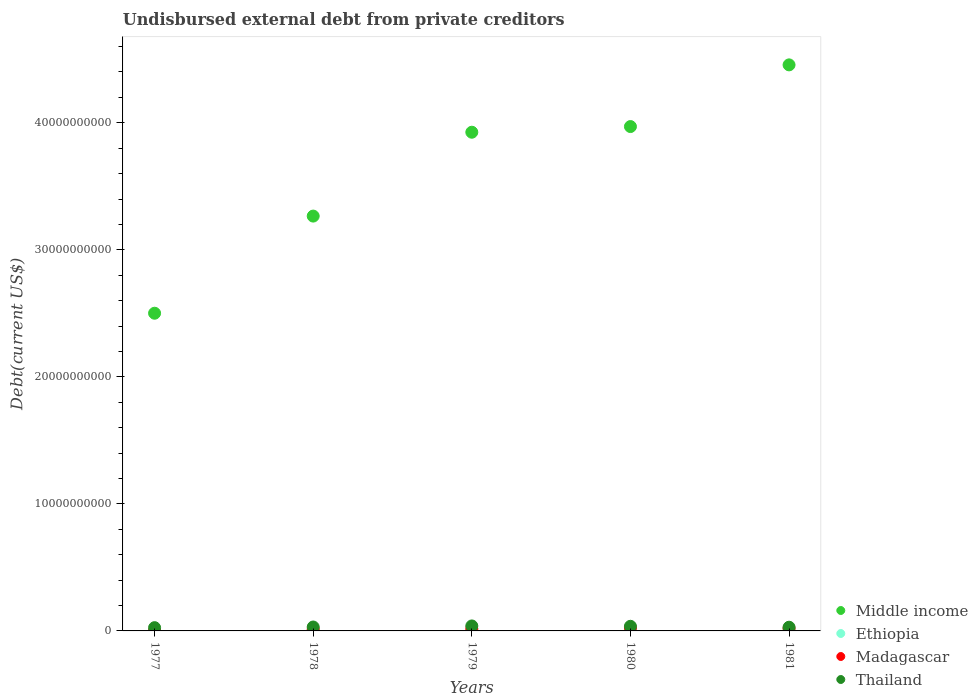Is the number of dotlines equal to the number of legend labels?
Provide a succinct answer. Yes. What is the total debt in Thailand in 1981?
Make the answer very short. 2.92e+08. Across all years, what is the maximum total debt in Middle income?
Provide a succinct answer. 4.46e+1. Across all years, what is the minimum total debt in Middle income?
Provide a short and direct response. 2.50e+1. In which year was the total debt in Ethiopia minimum?
Give a very brief answer. 1977. What is the total total debt in Thailand in the graph?
Make the answer very short. 1.61e+09. What is the difference between the total debt in Thailand in 1979 and that in 1981?
Provide a succinct answer. 9.95e+07. What is the difference between the total debt in Madagascar in 1981 and the total debt in Thailand in 1977?
Provide a short and direct response. -6.62e+07. What is the average total debt in Middle income per year?
Keep it short and to the point. 3.62e+1. In the year 1980, what is the difference between the total debt in Thailand and total debt in Ethiopia?
Offer a terse response. 3.11e+08. In how many years, is the total debt in Thailand greater than 44000000000 US$?
Offer a very short reply. 0. What is the ratio of the total debt in Madagascar in 1977 to that in 1978?
Keep it short and to the point. 0.12. Is the total debt in Middle income in 1977 less than that in 1979?
Your answer should be very brief. Yes. Is the difference between the total debt in Thailand in 1977 and 1980 greater than the difference between the total debt in Ethiopia in 1977 and 1980?
Your answer should be very brief. No. What is the difference between the highest and the second highest total debt in Ethiopia?
Your response must be concise. 1.24e+08. What is the difference between the highest and the lowest total debt in Thailand?
Offer a very short reply. 1.35e+08. Is it the case that in every year, the sum of the total debt in Madagascar and total debt in Ethiopia  is greater than the sum of total debt in Middle income and total debt in Thailand?
Your answer should be compact. No. Does the total debt in Ethiopia monotonically increase over the years?
Ensure brevity in your answer.  Yes. How many years are there in the graph?
Offer a terse response. 5. What is the difference between two consecutive major ticks on the Y-axis?
Provide a short and direct response. 1.00e+1. Are the values on the major ticks of Y-axis written in scientific E-notation?
Make the answer very short. No. Does the graph contain any zero values?
Offer a very short reply. No. Where does the legend appear in the graph?
Ensure brevity in your answer.  Bottom right. How many legend labels are there?
Your response must be concise. 4. How are the legend labels stacked?
Make the answer very short. Vertical. What is the title of the graph?
Ensure brevity in your answer.  Undisbursed external debt from private creditors. What is the label or title of the X-axis?
Ensure brevity in your answer.  Years. What is the label or title of the Y-axis?
Provide a short and direct response. Debt(current US$). What is the Debt(current US$) in Middle income in 1977?
Keep it short and to the point. 2.50e+1. What is the Debt(current US$) in Ethiopia in 1977?
Your response must be concise. 6.89e+06. What is the Debt(current US$) of Madagascar in 1977?
Ensure brevity in your answer.  1.63e+07. What is the Debt(current US$) of Thailand in 1977?
Offer a very short reply. 2.56e+08. What is the Debt(current US$) in Middle income in 1978?
Your answer should be very brief. 3.27e+1. What is the Debt(current US$) of Ethiopia in 1978?
Ensure brevity in your answer.  7.10e+06. What is the Debt(current US$) of Madagascar in 1978?
Offer a terse response. 1.31e+08. What is the Debt(current US$) in Thailand in 1978?
Your answer should be very brief. 3.08e+08. What is the Debt(current US$) of Middle income in 1979?
Provide a succinct answer. 3.93e+1. What is the Debt(current US$) in Ethiopia in 1979?
Make the answer very short. 2.71e+07. What is the Debt(current US$) of Madagascar in 1979?
Make the answer very short. 1.65e+08. What is the Debt(current US$) of Thailand in 1979?
Provide a succinct answer. 3.92e+08. What is the Debt(current US$) of Middle income in 1980?
Make the answer very short. 3.97e+1. What is the Debt(current US$) of Ethiopia in 1980?
Ensure brevity in your answer.  5.35e+07. What is the Debt(current US$) of Madagascar in 1980?
Offer a terse response. 2.41e+08. What is the Debt(current US$) of Thailand in 1980?
Your answer should be compact. 3.64e+08. What is the Debt(current US$) of Middle income in 1981?
Your answer should be compact. 4.46e+1. What is the Debt(current US$) of Ethiopia in 1981?
Ensure brevity in your answer.  1.78e+08. What is the Debt(current US$) in Madagascar in 1981?
Your answer should be very brief. 1.90e+08. What is the Debt(current US$) of Thailand in 1981?
Ensure brevity in your answer.  2.92e+08. Across all years, what is the maximum Debt(current US$) in Middle income?
Provide a short and direct response. 4.46e+1. Across all years, what is the maximum Debt(current US$) in Ethiopia?
Give a very brief answer. 1.78e+08. Across all years, what is the maximum Debt(current US$) in Madagascar?
Make the answer very short. 2.41e+08. Across all years, what is the maximum Debt(current US$) of Thailand?
Offer a very short reply. 3.92e+08. Across all years, what is the minimum Debt(current US$) in Middle income?
Your answer should be very brief. 2.50e+1. Across all years, what is the minimum Debt(current US$) in Ethiopia?
Keep it short and to the point. 6.89e+06. Across all years, what is the minimum Debt(current US$) in Madagascar?
Offer a very short reply. 1.63e+07. Across all years, what is the minimum Debt(current US$) in Thailand?
Your response must be concise. 2.56e+08. What is the total Debt(current US$) of Middle income in the graph?
Give a very brief answer. 1.81e+11. What is the total Debt(current US$) in Ethiopia in the graph?
Provide a short and direct response. 2.72e+08. What is the total Debt(current US$) of Madagascar in the graph?
Keep it short and to the point. 7.43e+08. What is the total Debt(current US$) in Thailand in the graph?
Give a very brief answer. 1.61e+09. What is the difference between the Debt(current US$) in Middle income in 1977 and that in 1978?
Keep it short and to the point. -7.65e+09. What is the difference between the Debt(current US$) of Ethiopia in 1977 and that in 1978?
Offer a terse response. -2.12e+05. What is the difference between the Debt(current US$) in Madagascar in 1977 and that in 1978?
Give a very brief answer. -1.15e+08. What is the difference between the Debt(current US$) in Thailand in 1977 and that in 1978?
Ensure brevity in your answer.  -5.21e+07. What is the difference between the Debt(current US$) of Middle income in 1977 and that in 1979?
Make the answer very short. -1.42e+1. What is the difference between the Debt(current US$) of Ethiopia in 1977 and that in 1979?
Offer a very short reply. -2.02e+07. What is the difference between the Debt(current US$) of Madagascar in 1977 and that in 1979?
Provide a succinct answer. -1.48e+08. What is the difference between the Debt(current US$) of Thailand in 1977 and that in 1979?
Keep it short and to the point. -1.35e+08. What is the difference between the Debt(current US$) in Middle income in 1977 and that in 1980?
Offer a terse response. -1.47e+1. What is the difference between the Debt(current US$) in Ethiopia in 1977 and that in 1980?
Provide a succinct answer. -4.66e+07. What is the difference between the Debt(current US$) in Madagascar in 1977 and that in 1980?
Provide a succinct answer. -2.25e+08. What is the difference between the Debt(current US$) of Thailand in 1977 and that in 1980?
Provide a short and direct response. -1.08e+08. What is the difference between the Debt(current US$) in Middle income in 1977 and that in 1981?
Provide a succinct answer. -1.96e+1. What is the difference between the Debt(current US$) of Ethiopia in 1977 and that in 1981?
Give a very brief answer. -1.71e+08. What is the difference between the Debt(current US$) of Madagascar in 1977 and that in 1981?
Your response must be concise. -1.74e+08. What is the difference between the Debt(current US$) in Thailand in 1977 and that in 1981?
Your response must be concise. -3.58e+07. What is the difference between the Debt(current US$) in Middle income in 1978 and that in 1979?
Give a very brief answer. -6.60e+09. What is the difference between the Debt(current US$) of Ethiopia in 1978 and that in 1979?
Ensure brevity in your answer.  -2.00e+07. What is the difference between the Debt(current US$) in Madagascar in 1978 and that in 1979?
Provide a succinct answer. -3.35e+07. What is the difference between the Debt(current US$) of Thailand in 1978 and that in 1979?
Offer a very short reply. -8.32e+07. What is the difference between the Debt(current US$) in Middle income in 1978 and that in 1980?
Your response must be concise. -7.05e+09. What is the difference between the Debt(current US$) of Ethiopia in 1978 and that in 1980?
Offer a terse response. -4.64e+07. What is the difference between the Debt(current US$) of Madagascar in 1978 and that in 1980?
Keep it short and to the point. -1.10e+08. What is the difference between the Debt(current US$) in Thailand in 1978 and that in 1980?
Keep it short and to the point. -5.60e+07. What is the difference between the Debt(current US$) in Middle income in 1978 and that in 1981?
Provide a succinct answer. -1.19e+1. What is the difference between the Debt(current US$) in Ethiopia in 1978 and that in 1981?
Provide a short and direct response. -1.71e+08. What is the difference between the Debt(current US$) in Madagascar in 1978 and that in 1981?
Give a very brief answer. -5.89e+07. What is the difference between the Debt(current US$) of Thailand in 1978 and that in 1981?
Keep it short and to the point. 1.63e+07. What is the difference between the Debt(current US$) in Middle income in 1979 and that in 1980?
Your response must be concise. -4.46e+08. What is the difference between the Debt(current US$) of Ethiopia in 1979 and that in 1980?
Your answer should be very brief. -2.64e+07. What is the difference between the Debt(current US$) of Madagascar in 1979 and that in 1980?
Provide a succinct answer. -7.65e+07. What is the difference between the Debt(current US$) of Thailand in 1979 and that in 1980?
Offer a very short reply. 2.72e+07. What is the difference between the Debt(current US$) of Middle income in 1979 and that in 1981?
Ensure brevity in your answer.  -5.30e+09. What is the difference between the Debt(current US$) in Ethiopia in 1979 and that in 1981?
Provide a short and direct response. -1.51e+08. What is the difference between the Debt(current US$) in Madagascar in 1979 and that in 1981?
Offer a very short reply. -2.54e+07. What is the difference between the Debt(current US$) in Thailand in 1979 and that in 1981?
Provide a short and direct response. 9.95e+07. What is the difference between the Debt(current US$) in Middle income in 1980 and that in 1981?
Make the answer very short. -4.86e+09. What is the difference between the Debt(current US$) in Ethiopia in 1980 and that in 1981?
Offer a very short reply. -1.24e+08. What is the difference between the Debt(current US$) of Madagascar in 1980 and that in 1981?
Make the answer very short. 5.11e+07. What is the difference between the Debt(current US$) in Thailand in 1980 and that in 1981?
Ensure brevity in your answer.  7.23e+07. What is the difference between the Debt(current US$) in Middle income in 1977 and the Debt(current US$) in Ethiopia in 1978?
Give a very brief answer. 2.50e+1. What is the difference between the Debt(current US$) of Middle income in 1977 and the Debt(current US$) of Madagascar in 1978?
Provide a succinct answer. 2.49e+1. What is the difference between the Debt(current US$) in Middle income in 1977 and the Debt(current US$) in Thailand in 1978?
Your answer should be compact. 2.47e+1. What is the difference between the Debt(current US$) of Ethiopia in 1977 and the Debt(current US$) of Madagascar in 1978?
Ensure brevity in your answer.  -1.24e+08. What is the difference between the Debt(current US$) in Ethiopia in 1977 and the Debt(current US$) in Thailand in 1978?
Give a very brief answer. -3.01e+08. What is the difference between the Debt(current US$) in Madagascar in 1977 and the Debt(current US$) in Thailand in 1978?
Ensure brevity in your answer.  -2.92e+08. What is the difference between the Debt(current US$) of Middle income in 1977 and the Debt(current US$) of Ethiopia in 1979?
Make the answer very short. 2.50e+1. What is the difference between the Debt(current US$) of Middle income in 1977 and the Debt(current US$) of Madagascar in 1979?
Offer a terse response. 2.48e+1. What is the difference between the Debt(current US$) of Middle income in 1977 and the Debt(current US$) of Thailand in 1979?
Give a very brief answer. 2.46e+1. What is the difference between the Debt(current US$) of Ethiopia in 1977 and the Debt(current US$) of Madagascar in 1979?
Make the answer very short. -1.58e+08. What is the difference between the Debt(current US$) in Ethiopia in 1977 and the Debt(current US$) in Thailand in 1979?
Provide a short and direct response. -3.85e+08. What is the difference between the Debt(current US$) in Madagascar in 1977 and the Debt(current US$) in Thailand in 1979?
Your answer should be compact. -3.75e+08. What is the difference between the Debt(current US$) in Middle income in 1977 and the Debt(current US$) in Ethiopia in 1980?
Provide a short and direct response. 2.50e+1. What is the difference between the Debt(current US$) of Middle income in 1977 and the Debt(current US$) of Madagascar in 1980?
Your response must be concise. 2.48e+1. What is the difference between the Debt(current US$) of Middle income in 1977 and the Debt(current US$) of Thailand in 1980?
Make the answer very short. 2.46e+1. What is the difference between the Debt(current US$) in Ethiopia in 1977 and the Debt(current US$) in Madagascar in 1980?
Make the answer very short. -2.34e+08. What is the difference between the Debt(current US$) in Ethiopia in 1977 and the Debt(current US$) in Thailand in 1980?
Your answer should be compact. -3.57e+08. What is the difference between the Debt(current US$) of Madagascar in 1977 and the Debt(current US$) of Thailand in 1980?
Provide a succinct answer. -3.48e+08. What is the difference between the Debt(current US$) of Middle income in 1977 and the Debt(current US$) of Ethiopia in 1981?
Provide a short and direct response. 2.48e+1. What is the difference between the Debt(current US$) of Middle income in 1977 and the Debt(current US$) of Madagascar in 1981?
Your response must be concise. 2.48e+1. What is the difference between the Debt(current US$) of Middle income in 1977 and the Debt(current US$) of Thailand in 1981?
Ensure brevity in your answer.  2.47e+1. What is the difference between the Debt(current US$) of Ethiopia in 1977 and the Debt(current US$) of Madagascar in 1981?
Offer a terse response. -1.83e+08. What is the difference between the Debt(current US$) of Ethiopia in 1977 and the Debt(current US$) of Thailand in 1981?
Provide a succinct answer. -2.85e+08. What is the difference between the Debt(current US$) in Madagascar in 1977 and the Debt(current US$) in Thailand in 1981?
Your answer should be very brief. -2.76e+08. What is the difference between the Debt(current US$) of Middle income in 1978 and the Debt(current US$) of Ethiopia in 1979?
Make the answer very short. 3.26e+1. What is the difference between the Debt(current US$) in Middle income in 1978 and the Debt(current US$) in Madagascar in 1979?
Make the answer very short. 3.25e+1. What is the difference between the Debt(current US$) of Middle income in 1978 and the Debt(current US$) of Thailand in 1979?
Offer a terse response. 3.23e+1. What is the difference between the Debt(current US$) in Ethiopia in 1978 and the Debt(current US$) in Madagascar in 1979?
Offer a terse response. -1.58e+08. What is the difference between the Debt(current US$) in Ethiopia in 1978 and the Debt(current US$) in Thailand in 1979?
Offer a very short reply. -3.84e+08. What is the difference between the Debt(current US$) of Madagascar in 1978 and the Debt(current US$) of Thailand in 1979?
Offer a terse response. -2.60e+08. What is the difference between the Debt(current US$) of Middle income in 1978 and the Debt(current US$) of Ethiopia in 1980?
Your answer should be compact. 3.26e+1. What is the difference between the Debt(current US$) of Middle income in 1978 and the Debt(current US$) of Madagascar in 1980?
Your response must be concise. 3.24e+1. What is the difference between the Debt(current US$) in Middle income in 1978 and the Debt(current US$) in Thailand in 1980?
Ensure brevity in your answer.  3.23e+1. What is the difference between the Debt(current US$) of Ethiopia in 1978 and the Debt(current US$) of Madagascar in 1980?
Your answer should be compact. -2.34e+08. What is the difference between the Debt(current US$) in Ethiopia in 1978 and the Debt(current US$) in Thailand in 1980?
Your answer should be compact. -3.57e+08. What is the difference between the Debt(current US$) of Madagascar in 1978 and the Debt(current US$) of Thailand in 1980?
Offer a very short reply. -2.33e+08. What is the difference between the Debt(current US$) of Middle income in 1978 and the Debt(current US$) of Ethiopia in 1981?
Provide a succinct answer. 3.25e+1. What is the difference between the Debt(current US$) in Middle income in 1978 and the Debt(current US$) in Madagascar in 1981?
Give a very brief answer. 3.25e+1. What is the difference between the Debt(current US$) in Middle income in 1978 and the Debt(current US$) in Thailand in 1981?
Keep it short and to the point. 3.24e+1. What is the difference between the Debt(current US$) in Ethiopia in 1978 and the Debt(current US$) in Madagascar in 1981?
Your response must be concise. -1.83e+08. What is the difference between the Debt(current US$) of Ethiopia in 1978 and the Debt(current US$) of Thailand in 1981?
Ensure brevity in your answer.  -2.85e+08. What is the difference between the Debt(current US$) of Madagascar in 1978 and the Debt(current US$) of Thailand in 1981?
Provide a short and direct response. -1.61e+08. What is the difference between the Debt(current US$) in Middle income in 1979 and the Debt(current US$) in Ethiopia in 1980?
Ensure brevity in your answer.  3.92e+1. What is the difference between the Debt(current US$) in Middle income in 1979 and the Debt(current US$) in Madagascar in 1980?
Offer a very short reply. 3.90e+1. What is the difference between the Debt(current US$) in Middle income in 1979 and the Debt(current US$) in Thailand in 1980?
Your response must be concise. 3.89e+1. What is the difference between the Debt(current US$) of Ethiopia in 1979 and the Debt(current US$) of Madagascar in 1980?
Provide a short and direct response. -2.14e+08. What is the difference between the Debt(current US$) of Ethiopia in 1979 and the Debt(current US$) of Thailand in 1980?
Provide a short and direct response. -3.37e+08. What is the difference between the Debt(current US$) of Madagascar in 1979 and the Debt(current US$) of Thailand in 1980?
Your response must be concise. -2.00e+08. What is the difference between the Debt(current US$) in Middle income in 1979 and the Debt(current US$) in Ethiopia in 1981?
Offer a terse response. 3.91e+1. What is the difference between the Debt(current US$) of Middle income in 1979 and the Debt(current US$) of Madagascar in 1981?
Your answer should be compact. 3.91e+1. What is the difference between the Debt(current US$) of Middle income in 1979 and the Debt(current US$) of Thailand in 1981?
Provide a succinct answer. 3.90e+1. What is the difference between the Debt(current US$) of Ethiopia in 1979 and the Debt(current US$) of Madagascar in 1981?
Your response must be concise. -1.63e+08. What is the difference between the Debt(current US$) in Ethiopia in 1979 and the Debt(current US$) in Thailand in 1981?
Keep it short and to the point. -2.65e+08. What is the difference between the Debt(current US$) of Madagascar in 1979 and the Debt(current US$) of Thailand in 1981?
Keep it short and to the point. -1.27e+08. What is the difference between the Debt(current US$) of Middle income in 1980 and the Debt(current US$) of Ethiopia in 1981?
Provide a short and direct response. 3.95e+1. What is the difference between the Debt(current US$) in Middle income in 1980 and the Debt(current US$) in Madagascar in 1981?
Provide a succinct answer. 3.95e+1. What is the difference between the Debt(current US$) in Middle income in 1980 and the Debt(current US$) in Thailand in 1981?
Provide a succinct answer. 3.94e+1. What is the difference between the Debt(current US$) of Ethiopia in 1980 and the Debt(current US$) of Madagascar in 1981?
Offer a very short reply. -1.37e+08. What is the difference between the Debt(current US$) of Ethiopia in 1980 and the Debt(current US$) of Thailand in 1981?
Ensure brevity in your answer.  -2.39e+08. What is the difference between the Debt(current US$) in Madagascar in 1980 and the Debt(current US$) in Thailand in 1981?
Your answer should be compact. -5.09e+07. What is the average Debt(current US$) of Middle income per year?
Provide a succinct answer. 3.62e+1. What is the average Debt(current US$) of Ethiopia per year?
Offer a terse response. 5.45e+07. What is the average Debt(current US$) in Madagascar per year?
Your answer should be compact. 1.49e+08. What is the average Debt(current US$) in Thailand per year?
Your answer should be very brief. 3.23e+08. In the year 1977, what is the difference between the Debt(current US$) of Middle income and Debt(current US$) of Ethiopia?
Offer a very short reply. 2.50e+1. In the year 1977, what is the difference between the Debt(current US$) of Middle income and Debt(current US$) of Madagascar?
Your answer should be compact. 2.50e+1. In the year 1977, what is the difference between the Debt(current US$) of Middle income and Debt(current US$) of Thailand?
Your answer should be very brief. 2.48e+1. In the year 1977, what is the difference between the Debt(current US$) in Ethiopia and Debt(current US$) in Madagascar?
Make the answer very short. -9.42e+06. In the year 1977, what is the difference between the Debt(current US$) in Ethiopia and Debt(current US$) in Thailand?
Give a very brief answer. -2.49e+08. In the year 1977, what is the difference between the Debt(current US$) in Madagascar and Debt(current US$) in Thailand?
Give a very brief answer. -2.40e+08. In the year 1978, what is the difference between the Debt(current US$) in Middle income and Debt(current US$) in Ethiopia?
Provide a short and direct response. 3.26e+1. In the year 1978, what is the difference between the Debt(current US$) in Middle income and Debt(current US$) in Madagascar?
Provide a short and direct response. 3.25e+1. In the year 1978, what is the difference between the Debt(current US$) of Middle income and Debt(current US$) of Thailand?
Give a very brief answer. 3.23e+1. In the year 1978, what is the difference between the Debt(current US$) in Ethiopia and Debt(current US$) in Madagascar?
Provide a short and direct response. -1.24e+08. In the year 1978, what is the difference between the Debt(current US$) in Ethiopia and Debt(current US$) in Thailand?
Provide a succinct answer. -3.01e+08. In the year 1978, what is the difference between the Debt(current US$) in Madagascar and Debt(current US$) in Thailand?
Keep it short and to the point. -1.77e+08. In the year 1979, what is the difference between the Debt(current US$) of Middle income and Debt(current US$) of Ethiopia?
Keep it short and to the point. 3.92e+1. In the year 1979, what is the difference between the Debt(current US$) in Middle income and Debt(current US$) in Madagascar?
Offer a terse response. 3.91e+1. In the year 1979, what is the difference between the Debt(current US$) of Middle income and Debt(current US$) of Thailand?
Give a very brief answer. 3.89e+1. In the year 1979, what is the difference between the Debt(current US$) in Ethiopia and Debt(current US$) in Madagascar?
Ensure brevity in your answer.  -1.38e+08. In the year 1979, what is the difference between the Debt(current US$) in Ethiopia and Debt(current US$) in Thailand?
Make the answer very short. -3.64e+08. In the year 1979, what is the difference between the Debt(current US$) of Madagascar and Debt(current US$) of Thailand?
Make the answer very short. -2.27e+08. In the year 1980, what is the difference between the Debt(current US$) in Middle income and Debt(current US$) in Ethiopia?
Ensure brevity in your answer.  3.97e+1. In the year 1980, what is the difference between the Debt(current US$) of Middle income and Debt(current US$) of Madagascar?
Provide a short and direct response. 3.95e+1. In the year 1980, what is the difference between the Debt(current US$) of Middle income and Debt(current US$) of Thailand?
Ensure brevity in your answer.  3.93e+1. In the year 1980, what is the difference between the Debt(current US$) in Ethiopia and Debt(current US$) in Madagascar?
Provide a succinct answer. -1.88e+08. In the year 1980, what is the difference between the Debt(current US$) of Ethiopia and Debt(current US$) of Thailand?
Your answer should be compact. -3.11e+08. In the year 1980, what is the difference between the Debt(current US$) of Madagascar and Debt(current US$) of Thailand?
Offer a terse response. -1.23e+08. In the year 1981, what is the difference between the Debt(current US$) in Middle income and Debt(current US$) in Ethiopia?
Your answer should be compact. 4.44e+1. In the year 1981, what is the difference between the Debt(current US$) of Middle income and Debt(current US$) of Madagascar?
Provide a short and direct response. 4.44e+1. In the year 1981, what is the difference between the Debt(current US$) in Middle income and Debt(current US$) in Thailand?
Your response must be concise. 4.43e+1. In the year 1981, what is the difference between the Debt(current US$) in Ethiopia and Debt(current US$) in Madagascar?
Provide a short and direct response. -1.22e+07. In the year 1981, what is the difference between the Debt(current US$) in Ethiopia and Debt(current US$) in Thailand?
Your response must be concise. -1.14e+08. In the year 1981, what is the difference between the Debt(current US$) in Madagascar and Debt(current US$) in Thailand?
Your answer should be compact. -1.02e+08. What is the ratio of the Debt(current US$) of Middle income in 1977 to that in 1978?
Your answer should be very brief. 0.77. What is the ratio of the Debt(current US$) of Ethiopia in 1977 to that in 1978?
Offer a terse response. 0.97. What is the ratio of the Debt(current US$) of Madagascar in 1977 to that in 1978?
Provide a short and direct response. 0.12. What is the ratio of the Debt(current US$) in Thailand in 1977 to that in 1978?
Your answer should be compact. 0.83. What is the ratio of the Debt(current US$) of Middle income in 1977 to that in 1979?
Offer a terse response. 0.64. What is the ratio of the Debt(current US$) of Ethiopia in 1977 to that in 1979?
Offer a very short reply. 0.25. What is the ratio of the Debt(current US$) of Madagascar in 1977 to that in 1979?
Keep it short and to the point. 0.1. What is the ratio of the Debt(current US$) of Thailand in 1977 to that in 1979?
Offer a very short reply. 0.65. What is the ratio of the Debt(current US$) of Middle income in 1977 to that in 1980?
Keep it short and to the point. 0.63. What is the ratio of the Debt(current US$) in Ethiopia in 1977 to that in 1980?
Provide a succinct answer. 0.13. What is the ratio of the Debt(current US$) in Madagascar in 1977 to that in 1980?
Give a very brief answer. 0.07. What is the ratio of the Debt(current US$) in Thailand in 1977 to that in 1980?
Make the answer very short. 0.7. What is the ratio of the Debt(current US$) in Middle income in 1977 to that in 1981?
Keep it short and to the point. 0.56. What is the ratio of the Debt(current US$) in Ethiopia in 1977 to that in 1981?
Make the answer very short. 0.04. What is the ratio of the Debt(current US$) in Madagascar in 1977 to that in 1981?
Keep it short and to the point. 0.09. What is the ratio of the Debt(current US$) in Thailand in 1977 to that in 1981?
Your response must be concise. 0.88. What is the ratio of the Debt(current US$) in Middle income in 1978 to that in 1979?
Make the answer very short. 0.83. What is the ratio of the Debt(current US$) of Ethiopia in 1978 to that in 1979?
Ensure brevity in your answer.  0.26. What is the ratio of the Debt(current US$) in Madagascar in 1978 to that in 1979?
Make the answer very short. 0.8. What is the ratio of the Debt(current US$) of Thailand in 1978 to that in 1979?
Your response must be concise. 0.79. What is the ratio of the Debt(current US$) of Middle income in 1978 to that in 1980?
Your answer should be compact. 0.82. What is the ratio of the Debt(current US$) in Ethiopia in 1978 to that in 1980?
Your response must be concise. 0.13. What is the ratio of the Debt(current US$) in Madagascar in 1978 to that in 1980?
Give a very brief answer. 0.54. What is the ratio of the Debt(current US$) in Thailand in 1978 to that in 1980?
Your answer should be very brief. 0.85. What is the ratio of the Debt(current US$) of Middle income in 1978 to that in 1981?
Offer a terse response. 0.73. What is the ratio of the Debt(current US$) of Ethiopia in 1978 to that in 1981?
Make the answer very short. 0.04. What is the ratio of the Debt(current US$) in Madagascar in 1978 to that in 1981?
Offer a very short reply. 0.69. What is the ratio of the Debt(current US$) in Thailand in 1978 to that in 1981?
Make the answer very short. 1.06. What is the ratio of the Debt(current US$) of Middle income in 1979 to that in 1980?
Provide a short and direct response. 0.99. What is the ratio of the Debt(current US$) of Ethiopia in 1979 to that in 1980?
Ensure brevity in your answer.  0.51. What is the ratio of the Debt(current US$) in Madagascar in 1979 to that in 1980?
Offer a very short reply. 0.68. What is the ratio of the Debt(current US$) of Thailand in 1979 to that in 1980?
Ensure brevity in your answer.  1.07. What is the ratio of the Debt(current US$) in Middle income in 1979 to that in 1981?
Provide a succinct answer. 0.88. What is the ratio of the Debt(current US$) of Ethiopia in 1979 to that in 1981?
Your answer should be very brief. 0.15. What is the ratio of the Debt(current US$) of Madagascar in 1979 to that in 1981?
Ensure brevity in your answer.  0.87. What is the ratio of the Debt(current US$) of Thailand in 1979 to that in 1981?
Provide a short and direct response. 1.34. What is the ratio of the Debt(current US$) of Middle income in 1980 to that in 1981?
Your answer should be very brief. 0.89. What is the ratio of the Debt(current US$) in Ethiopia in 1980 to that in 1981?
Give a very brief answer. 0.3. What is the ratio of the Debt(current US$) in Madagascar in 1980 to that in 1981?
Your response must be concise. 1.27. What is the ratio of the Debt(current US$) of Thailand in 1980 to that in 1981?
Offer a terse response. 1.25. What is the difference between the highest and the second highest Debt(current US$) in Middle income?
Offer a terse response. 4.86e+09. What is the difference between the highest and the second highest Debt(current US$) in Ethiopia?
Provide a succinct answer. 1.24e+08. What is the difference between the highest and the second highest Debt(current US$) in Madagascar?
Give a very brief answer. 5.11e+07. What is the difference between the highest and the second highest Debt(current US$) in Thailand?
Offer a terse response. 2.72e+07. What is the difference between the highest and the lowest Debt(current US$) in Middle income?
Provide a short and direct response. 1.96e+1. What is the difference between the highest and the lowest Debt(current US$) in Ethiopia?
Your response must be concise. 1.71e+08. What is the difference between the highest and the lowest Debt(current US$) in Madagascar?
Your answer should be very brief. 2.25e+08. What is the difference between the highest and the lowest Debt(current US$) of Thailand?
Your answer should be very brief. 1.35e+08. 